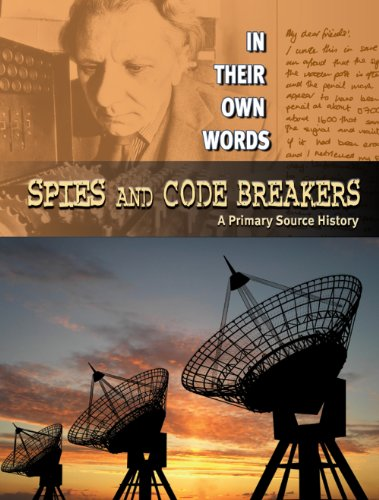Is this a religious book? No, this book is not religious in nature; it focuses on historical events related to spies and code breakers. 